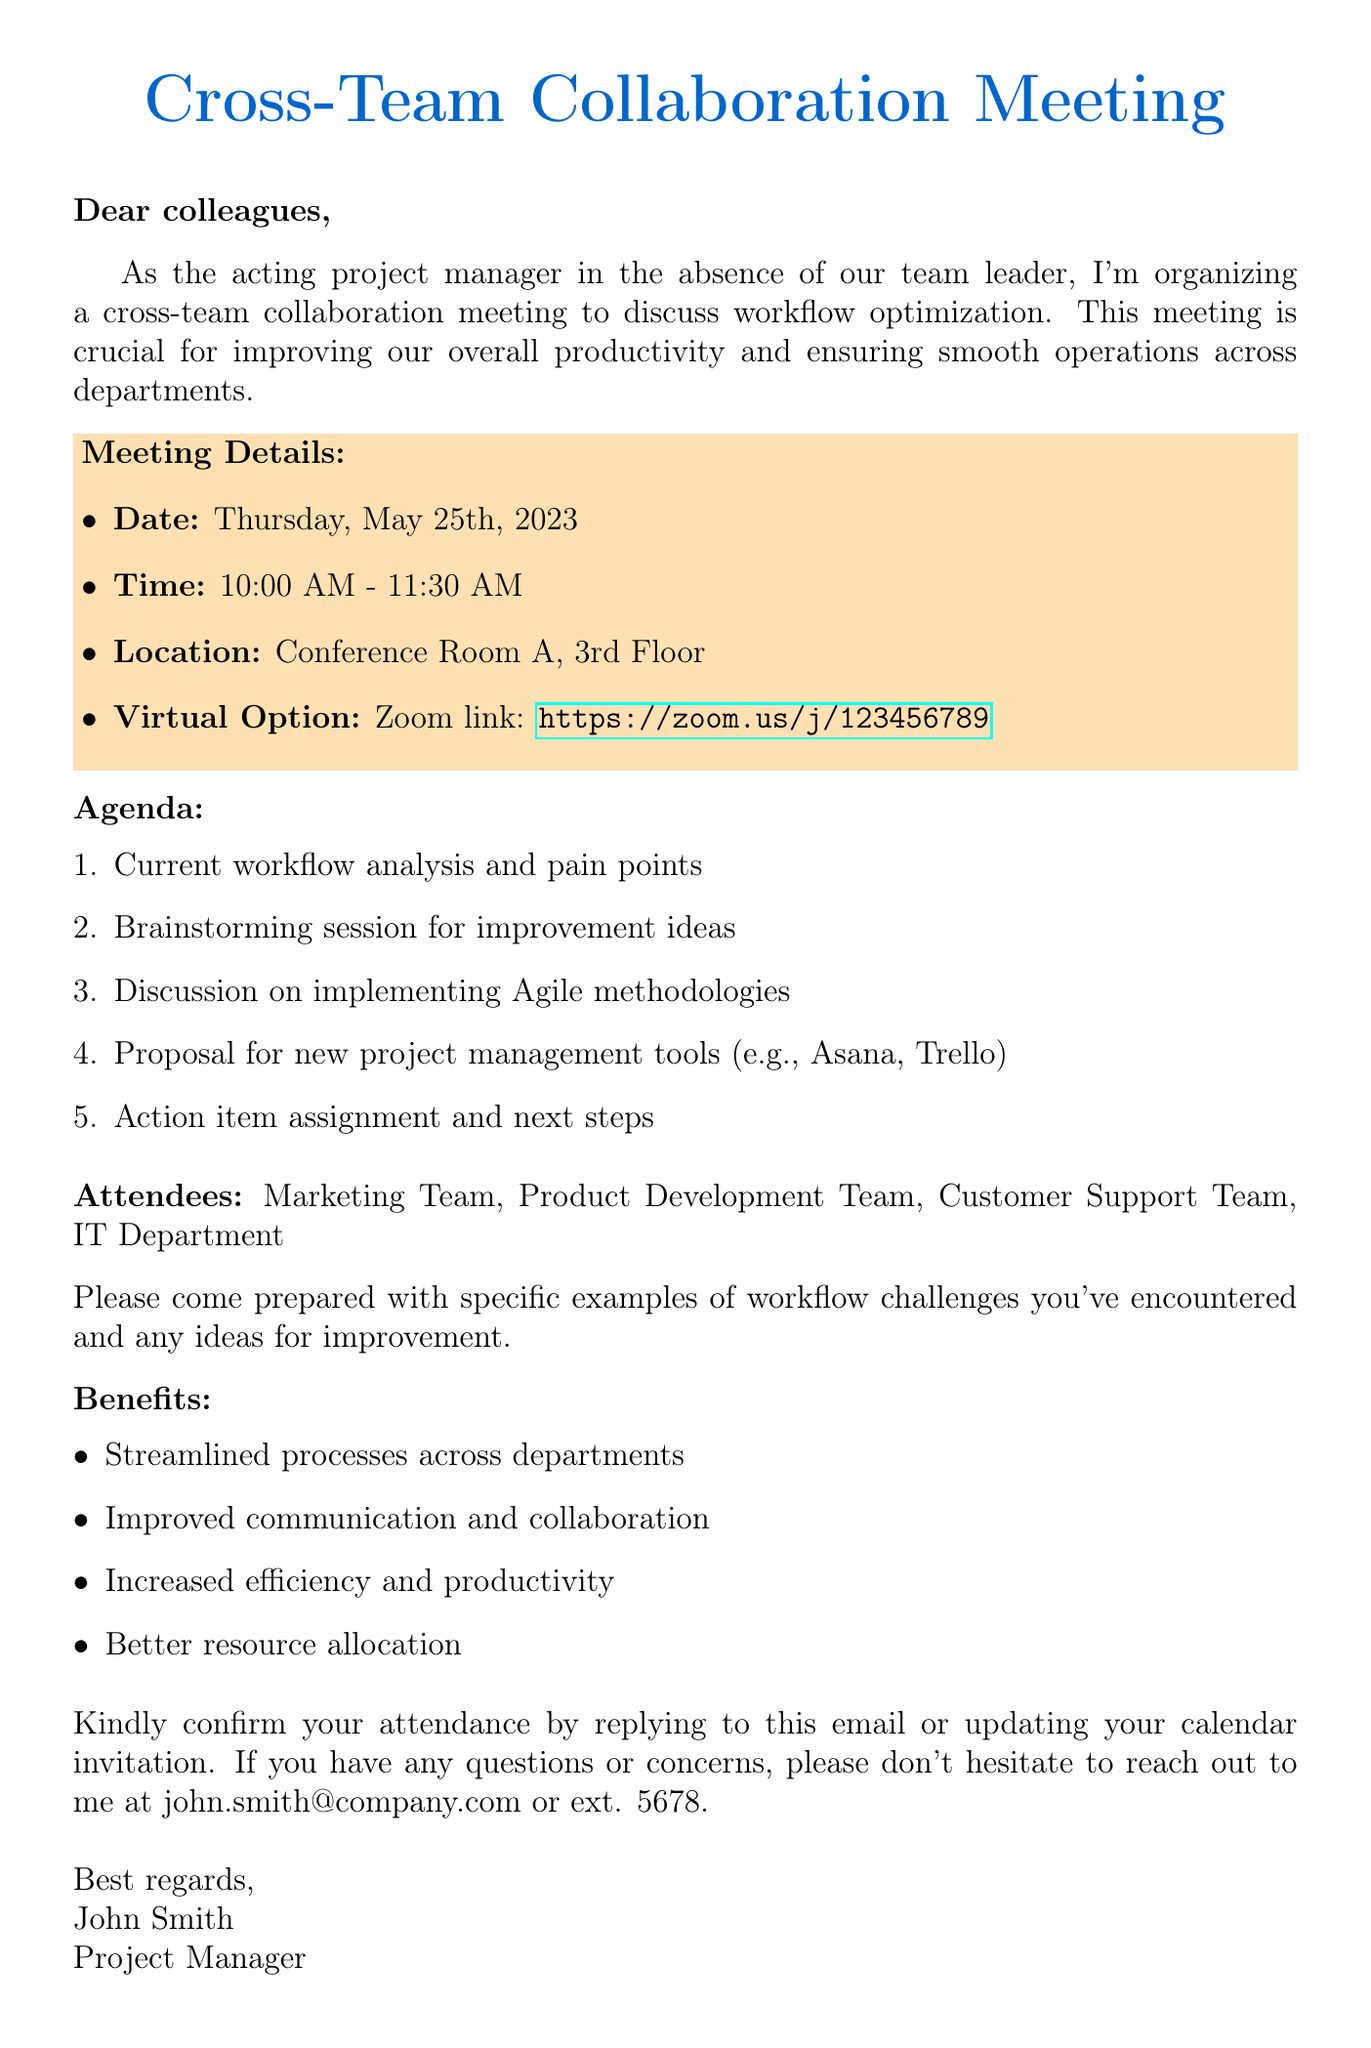What is the date of the meeting? The date of the meeting is specified in the meeting details section.
Answer: Thursday, May 25th, 2023 What is the location of the meeting? The location is mentioned in the meeting details section.
Answer: Conference Room A, 3rd Floor Who is organizing the meeting? The introduction states who is organizing the meeting.
Answer: John Smith What is one agenda item for the meeting? The agenda items are listed in a numbered format.
Answer: Current workflow analysis and pain points What option is provided for virtual attendance? The virtual option is included in the meeting details.
Answer: Zoom link: https://zoom.us/j/123456789 What should attendees prepare for the meeting? The preparation request indicates what attendees need to bring.
Answer: Specific examples of workflow challenges What is one benefit of this meeting? The benefits are listed in a bullet format.
Answer: Streamlined processes across departments How long is the meeting scheduled to last? The time duration is provided in the meeting details.
Answer: 1 hour 30 minutes Who should attendees contact for questions? The contact information for inquiries is located in the closing section.
Answer: john.smith@company.com 